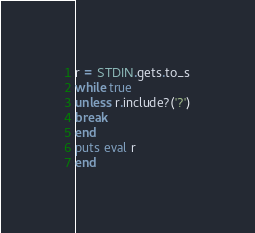<code> <loc_0><loc_0><loc_500><loc_500><_Ruby_>r = STDIN.gets.to_s
while true
unless r.include?('?')
break
end
puts eval r
end</code> 